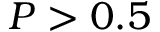<formula> <loc_0><loc_0><loc_500><loc_500>P > 0 . 5</formula> 